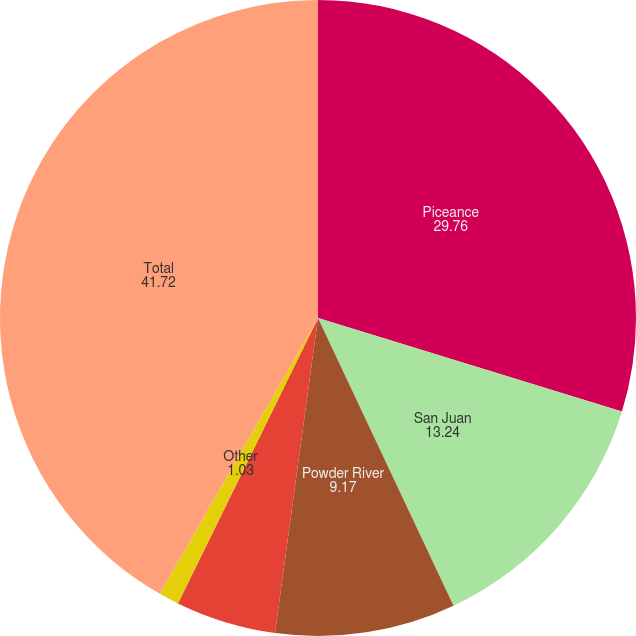Convert chart. <chart><loc_0><loc_0><loc_500><loc_500><pie_chart><fcel>Piceance<fcel>San Juan<fcel>Powder River<fcel>Mid-Continent<fcel>Other<fcel>Total<nl><fcel>29.76%<fcel>13.24%<fcel>9.17%<fcel>5.1%<fcel>1.03%<fcel>41.72%<nl></chart> 